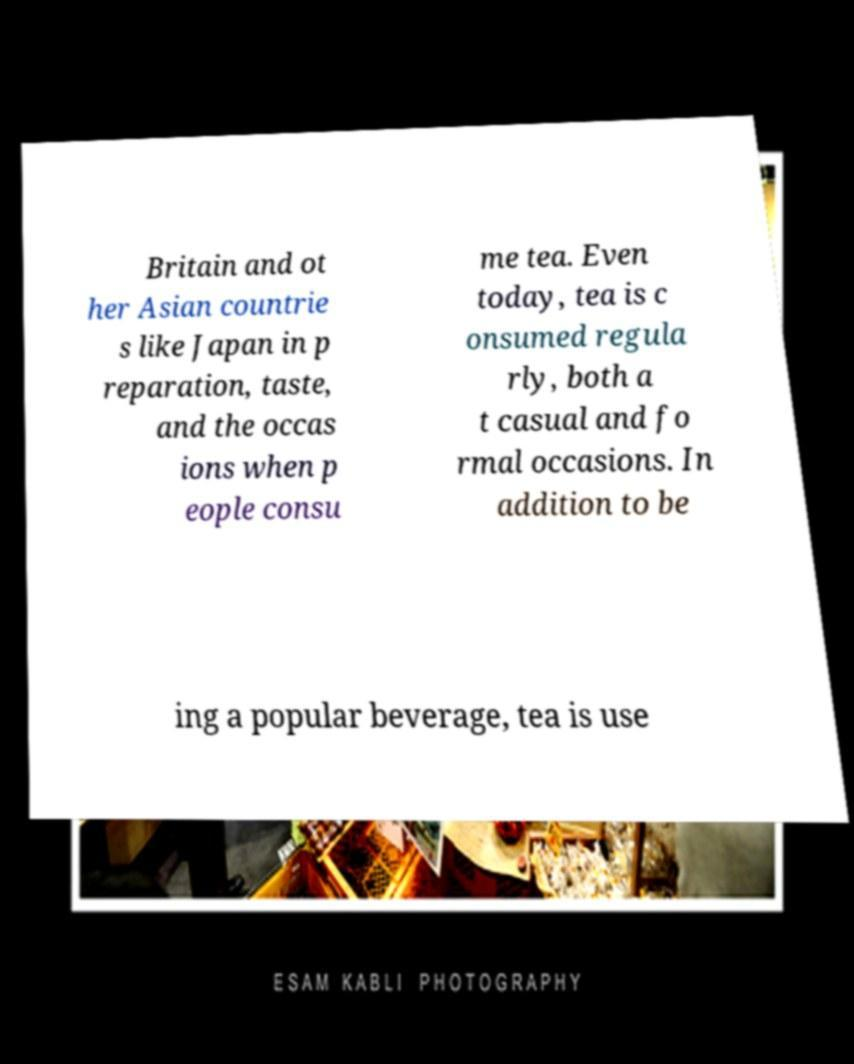Can you accurately transcribe the text from the provided image for me? Britain and ot her Asian countrie s like Japan in p reparation, taste, and the occas ions when p eople consu me tea. Even today, tea is c onsumed regula rly, both a t casual and fo rmal occasions. In addition to be ing a popular beverage, tea is use 